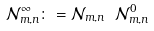<formula> <loc_0><loc_0><loc_500><loc_500>\mathcal { N } _ { m , n } ^ { \infty } \colon = \mathcal { N } _ { m , n } \ \mathcal { N } _ { m , n } ^ { 0 }</formula> 